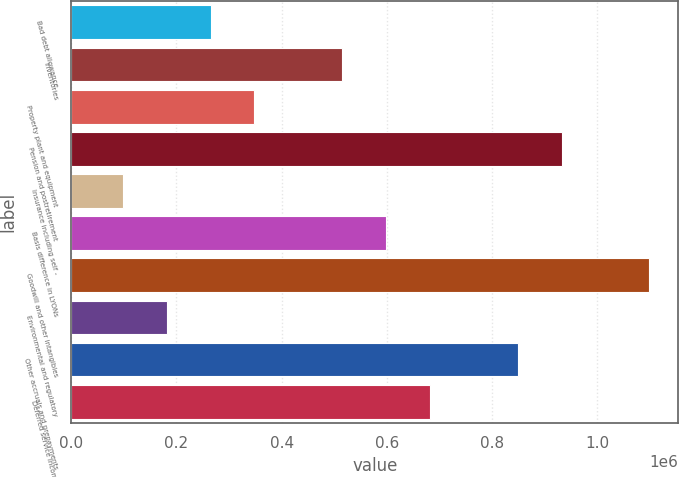<chart> <loc_0><loc_0><loc_500><loc_500><bar_chart><fcel>Bad debt allowance<fcel>Inventories<fcel>Property plant and equipment<fcel>Pension and postretirement<fcel>Insurance including self -<fcel>Basis difference in LYONs<fcel>Goodwill and other intangibles<fcel>Environmental and regulatory<fcel>Other accruals and prepayments<fcel>Deferred service income<nl><fcel>264900<fcel>515406<fcel>348402<fcel>932916<fcel>97896<fcel>598908<fcel>1.09992e+06<fcel>181398<fcel>849414<fcel>682410<nl></chart> 